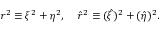Convert formula to latex. <formula><loc_0><loc_0><loc_500><loc_500>r ^ { 2 } \equiv \xi ^ { 2 } + \eta ^ { 2 } , \, \hat { r } ^ { 2 } \equiv ( \hat { \xi } ) ^ { 2 } + ( \hat { \eta } ) ^ { 2 } .</formula> 